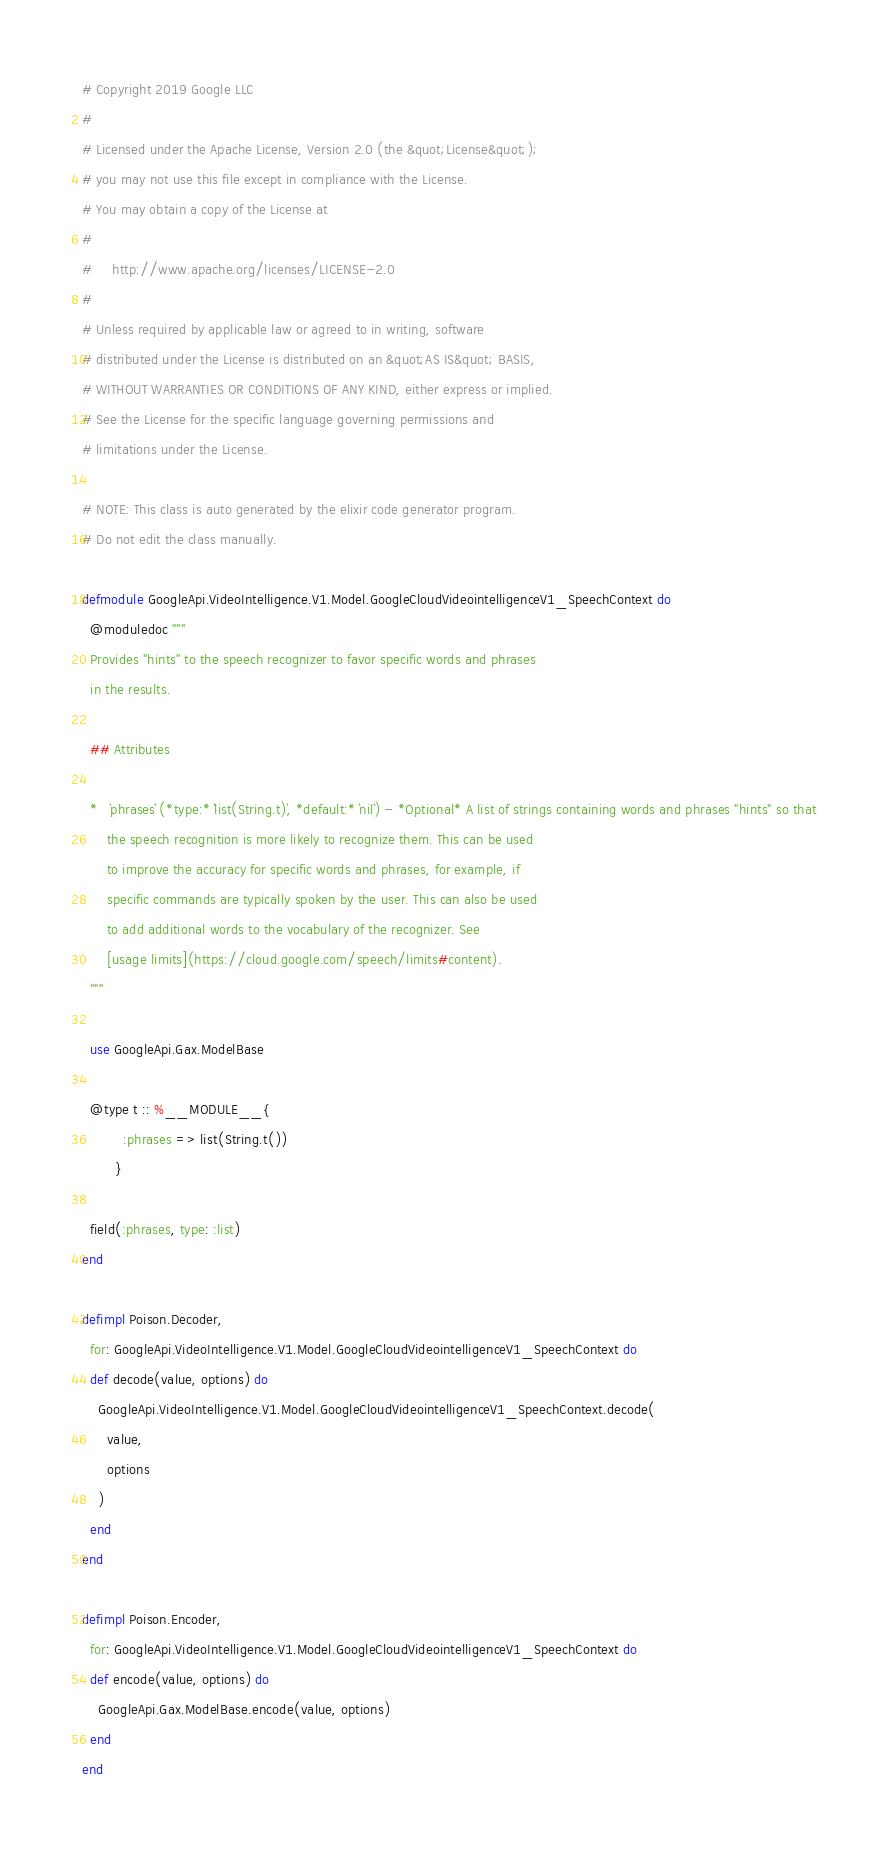Convert code to text. <code><loc_0><loc_0><loc_500><loc_500><_Elixir_># Copyright 2019 Google LLC
#
# Licensed under the Apache License, Version 2.0 (the &quot;License&quot;);
# you may not use this file except in compliance with the License.
# You may obtain a copy of the License at
#
#     http://www.apache.org/licenses/LICENSE-2.0
#
# Unless required by applicable law or agreed to in writing, software
# distributed under the License is distributed on an &quot;AS IS&quot; BASIS,
# WITHOUT WARRANTIES OR CONDITIONS OF ANY KIND, either express or implied.
# See the License for the specific language governing permissions and
# limitations under the License.

# NOTE: This class is auto generated by the elixir code generator program.
# Do not edit the class manually.

defmodule GoogleApi.VideoIntelligence.V1.Model.GoogleCloudVideointelligenceV1_SpeechContext do
  @moduledoc """
  Provides "hints" to the speech recognizer to favor specific words and phrases
  in the results.

  ## Attributes

  *   `phrases` (*type:* `list(String.t)`, *default:* `nil`) - *Optional* A list of strings containing words and phrases "hints" so that
      the speech recognition is more likely to recognize them. This can be used
      to improve the accuracy for specific words and phrases, for example, if
      specific commands are typically spoken by the user. This can also be used
      to add additional words to the vocabulary of the recognizer. See
      [usage limits](https://cloud.google.com/speech/limits#content).
  """

  use GoogleApi.Gax.ModelBase

  @type t :: %__MODULE__{
          :phrases => list(String.t())
        }

  field(:phrases, type: :list)
end

defimpl Poison.Decoder,
  for: GoogleApi.VideoIntelligence.V1.Model.GoogleCloudVideointelligenceV1_SpeechContext do
  def decode(value, options) do
    GoogleApi.VideoIntelligence.V1.Model.GoogleCloudVideointelligenceV1_SpeechContext.decode(
      value,
      options
    )
  end
end

defimpl Poison.Encoder,
  for: GoogleApi.VideoIntelligence.V1.Model.GoogleCloudVideointelligenceV1_SpeechContext do
  def encode(value, options) do
    GoogleApi.Gax.ModelBase.encode(value, options)
  end
end
</code> 